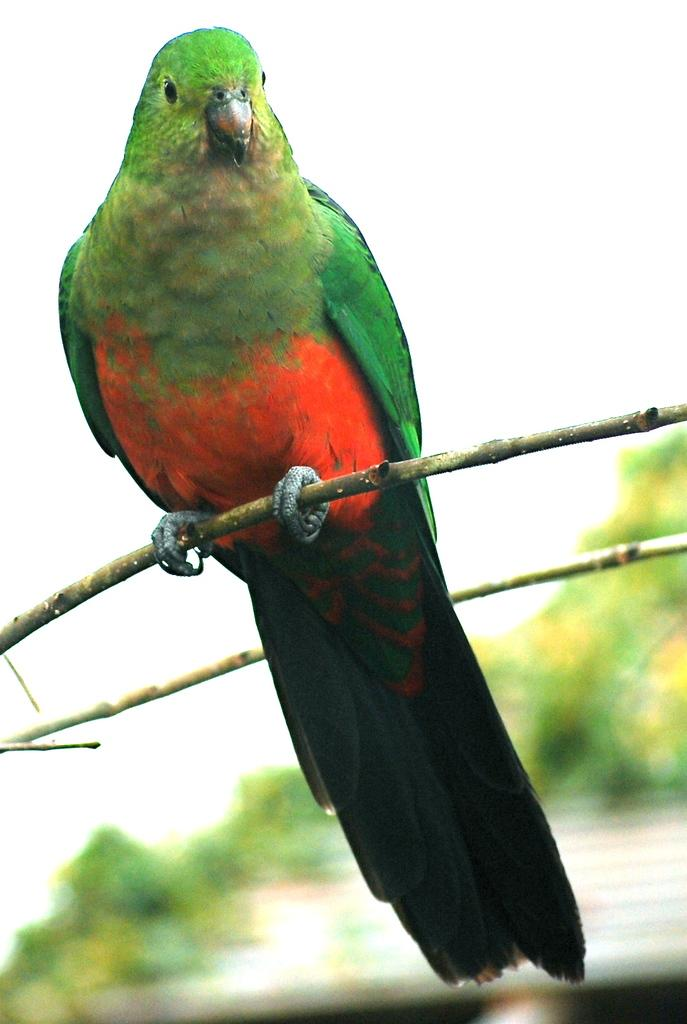What is the main subject in the center of the image? There is a bird in the center of the image. How is the bird positioned in the image? The bird is on a stick. What can be seen in the background of the image? There are trees in the background of the image. What type of sugar is being used to sweeten the bird's nest in the image? There is no bird's nest or sugar present in the image. 